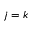Convert formula to latex. <formula><loc_0><loc_0><loc_500><loc_500>j = k</formula> 